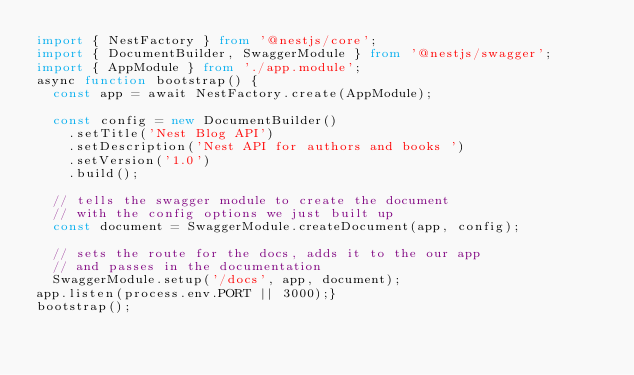Convert code to text. <code><loc_0><loc_0><loc_500><loc_500><_TypeScript_>import { NestFactory } from '@nestjs/core';
import { DocumentBuilder, SwaggerModule } from '@nestjs/swagger'; 
import { AppModule } from './app.module';
async function bootstrap() {
  const app = await NestFactory.create(AppModule);

  const config = new DocumentBuilder()
    .setTitle('Nest Blog API')
    .setDescription('Nest API for authors and books ')
    .setVersion('1.0')
    .build();

  // tells the swagger module to create the document
  // with the config options we just built up
  const document = SwaggerModule.createDocument(app, config);

  // sets the route for the docs, adds it to the our app
  // and passes in the documentation
  SwaggerModule.setup('/docs', app, document);
app.listen(process.env.PORT || 3000);}
bootstrap();
</code> 